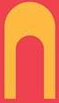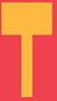What text is displayed in these images sequentially, separated by a semicolon? N; T 